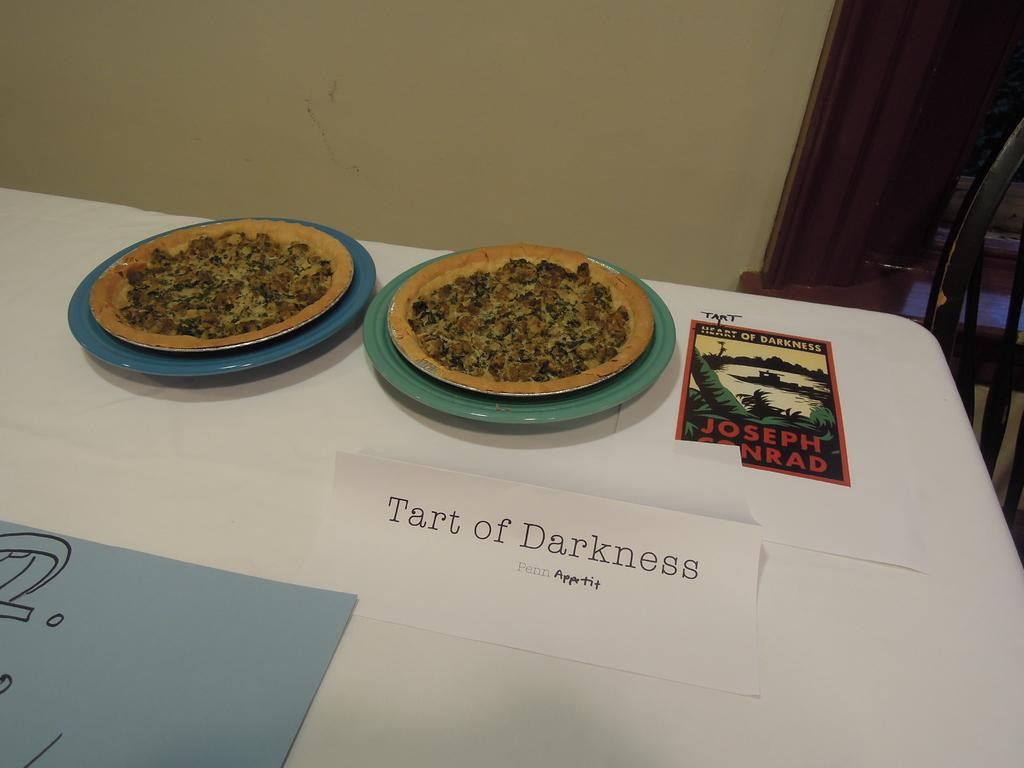What is unique about the planets in the image? The planets in the image have pizza. What can be seen hanging on the wall in the image? There is a poster in the image. What is present on the table in the image? There is an object on the table in the image. What architectural features are visible in the background of the image? There is a wall, a door, and a chair in the background of the image. How does the image depict the wealth of the person in the room? The image does not depict the wealth of the person in the room; it focuses on planets with pizza and other objects and features. 